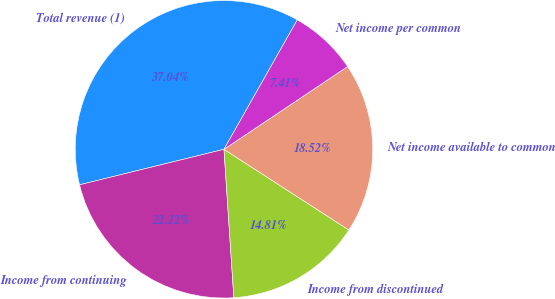<chart> <loc_0><loc_0><loc_500><loc_500><pie_chart><fcel>Total revenue (1)<fcel>Income from continuing<fcel>Income from discontinued<fcel>Net income available to common<fcel>Net income per common<nl><fcel>37.04%<fcel>22.22%<fcel>14.81%<fcel>18.52%<fcel>7.41%<nl></chart> 